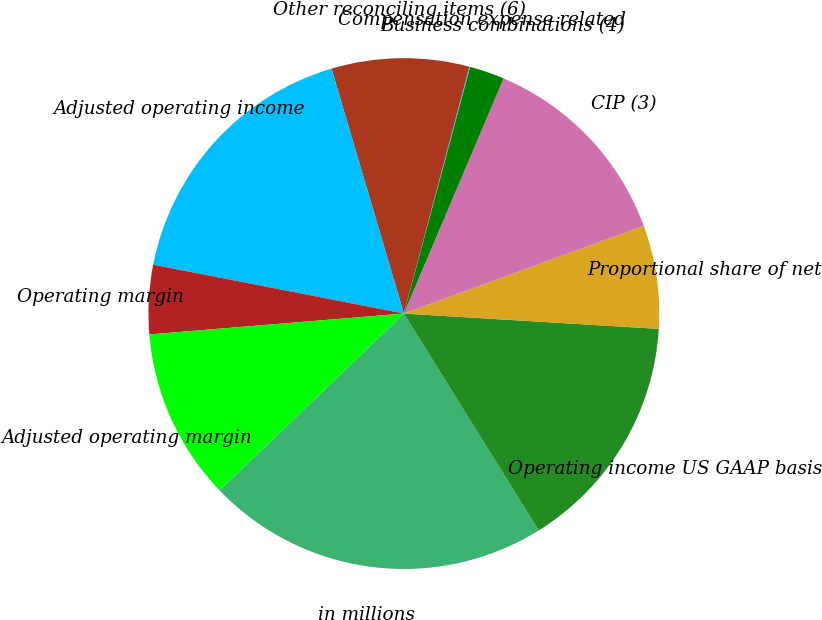Convert chart to OTSL. <chart><loc_0><loc_0><loc_500><loc_500><pie_chart><fcel>in millions<fcel>Operating income US GAAP basis<fcel>Proportional share of net<fcel>CIP (3)<fcel>Business combinations (4)<fcel>Compensation expense related<fcel>Other reconciling items (6)<fcel>Adjusted operating income<fcel>Operating margin<fcel>Adjusted operating margin<nl><fcel>21.68%<fcel>15.19%<fcel>6.54%<fcel>13.03%<fcel>2.21%<fcel>0.05%<fcel>8.7%<fcel>17.36%<fcel>4.37%<fcel>10.87%<nl></chart> 